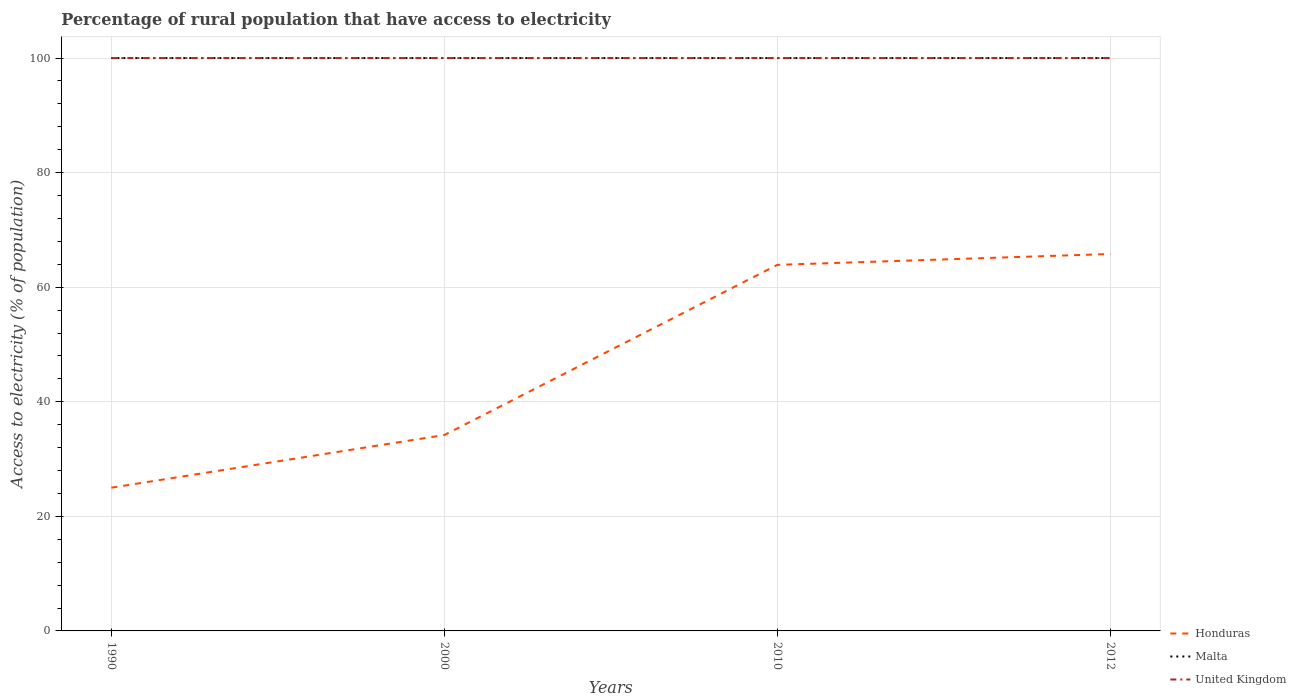How many different coloured lines are there?
Make the answer very short. 3. Does the line corresponding to Honduras intersect with the line corresponding to Malta?
Provide a succinct answer. No. Is the number of lines equal to the number of legend labels?
Provide a succinct answer. Yes. Across all years, what is the maximum percentage of rural population that have access to electricity in Malta?
Keep it short and to the point. 100. What is the difference between the highest and the second highest percentage of rural population that have access to electricity in Honduras?
Provide a short and direct response. 40.8. How many lines are there?
Provide a short and direct response. 3. What is the difference between two consecutive major ticks on the Y-axis?
Provide a short and direct response. 20. Are the values on the major ticks of Y-axis written in scientific E-notation?
Your answer should be compact. No. Does the graph contain grids?
Offer a terse response. Yes. Where does the legend appear in the graph?
Give a very brief answer. Bottom right. How are the legend labels stacked?
Offer a very short reply. Vertical. What is the title of the graph?
Offer a very short reply. Percentage of rural population that have access to electricity. What is the label or title of the X-axis?
Provide a succinct answer. Years. What is the label or title of the Y-axis?
Give a very brief answer. Access to electricity (% of population). What is the Access to electricity (% of population) of United Kingdom in 1990?
Ensure brevity in your answer.  100. What is the Access to electricity (% of population) in Honduras in 2000?
Your answer should be compact. 34.2. What is the Access to electricity (% of population) of Malta in 2000?
Make the answer very short. 100. What is the Access to electricity (% of population) of Honduras in 2010?
Give a very brief answer. 63.9. What is the Access to electricity (% of population) in Honduras in 2012?
Keep it short and to the point. 65.8. What is the Access to electricity (% of population) in Malta in 2012?
Give a very brief answer. 100. What is the Access to electricity (% of population) of United Kingdom in 2012?
Provide a short and direct response. 100. Across all years, what is the maximum Access to electricity (% of population) in Honduras?
Give a very brief answer. 65.8. Across all years, what is the maximum Access to electricity (% of population) in United Kingdom?
Give a very brief answer. 100. Across all years, what is the minimum Access to electricity (% of population) of Honduras?
Your response must be concise. 25. Across all years, what is the minimum Access to electricity (% of population) of Malta?
Provide a succinct answer. 100. Across all years, what is the minimum Access to electricity (% of population) in United Kingdom?
Offer a terse response. 100. What is the total Access to electricity (% of population) of Honduras in the graph?
Your response must be concise. 188.9. What is the total Access to electricity (% of population) in Malta in the graph?
Give a very brief answer. 400. What is the difference between the Access to electricity (% of population) in Malta in 1990 and that in 2000?
Give a very brief answer. 0. What is the difference between the Access to electricity (% of population) of Honduras in 1990 and that in 2010?
Your answer should be compact. -38.9. What is the difference between the Access to electricity (% of population) in Malta in 1990 and that in 2010?
Your answer should be very brief. 0. What is the difference between the Access to electricity (% of population) in United Kingdom in 1990 and that in 2010?
Give a very brief answer. 0. What is the difference between the Access to electricity (% of population) in Honduras in 1990 and that in 2012?
Provide a short and direct response. -40.8. What is the difference between the Access to electricity (% of population) in United Kingdom in 1990 and that in 2012?
Make the answer very short. 0. What is the difference between the Access to electricity (% of population) in Honduras in 2000 and that in 2010?
Offer a terse response. -29.7. What is the difference between the Access to electricity (% of population) in Malta in 2000 and that in 2010?
Provide a succinct answer. 0. What is the difference between the Access to electricity (% of population) in Honduras in 2000 and that in 2012?
Keep it short and to the point. -31.6. What is the difference between the Access to electricity (% of population) of United Kingdom in 2000 and that in 2012?
Your answer should be very brief. 0. What is the difference between the Access to electricity (% of population) in Honduras in 2010 and that in 2012?
Offer a terse response. -1.9. What is the difference between the Access to electricity (% of population) of Malta in 2010 and that in 2012?
Offer a very short reply. 0. What is the difference between the Access to electricity (% of population) in United Kingdom in 2010 and that in 2012?
Provide a succinct answer. 0. What is the difference between the Access to electricity (% of population) in Honduras in 1990 and the Access to electricity (% of population) in Malta in 2000?
Ensure brevity in your answer.  -75. What is the difference between the Access to electricity (% of population) in Honduras in 1990 and the Access to electricity (% of population) in United Kingdom in 2000?
Give a very brief answer. -75. What is the difference between the Access to electricity (% of population) in Malta in 1990 and the Access to electricity (% of population) in United Kingdom in 2000?
Provide a short and direct response. 0. What is the difference between the Access to electricity (% of population) in Honduras in 1990 and the Access to electricity (% of population) in Malta in 2010?
Your answer should be compact. -75. What is the difference between the Access to electricity (% of population) in Honduras in 1990 and the Access to electricity (% of population) in United Kingdom in 2010?
Keep it short and to the point. -75. What is the difference between the Access to electricity (% of population) of Malta in 1990 and the Access to electricity (% of population) of United Kingdom in 2010?
Keep it short and to the point. 0. What is the difference between the Access to electricity (% of population) in Honduras in 1990 and the Access to electricity (% of population) in Malta in 2012?
Your answer should be compact. -75. What is the difference between the Access to electricity (% of population) in Honduras in 1990 and the Access to electricity (% of population) in United Kingdom in 2012?
Offer a terse response. -75. What is the difference between the Access to electricity (% of population) of Malta in 1990 and the Access to electricity (% of population) of United Kingdom in 2012?
Provide a succinct answer. 0. What is the difference between the Access to electricity (% of population) in Honduras in 2000 and the Access to electricity (% of population) in Malta in 2010?
Give a very brief answer. -65.8. What is the difference between the Access to electricity (% of population) of Honduras in 2000 and the Access to electricity (% of population) of United Kingdom in 2010?
Ensure brevity in your answer.  -65.8. What is the difference between the Access to electricity (% of population) in Malta in 2000 and the Access to electricity (% of population) in United Kingdom in 2010?
Your response must be concise. 0. What is the difference between the Access to electricity (% of population) of Honduras in 2000 and the Access to electricity (% of population) of Malta in 2012?
Your answer should be very brief. -65.8. What is the difference between the Access to electricity (% of population) in Honduras in 2000 and the Access to electricity (% of population) in United Kingdom in 2012?
Your answer should be compact. -65.8. What is the difference between the Access to electricity (% of population) of Honduras in 2010 and the Access to electricity (% of population) of Malta in 2012?
Make the answer very short. -36.1. What is the difference between the Access to electricity (% of population) of Honduras in 2010 and the Access to electricity (% of population) of United Kingdom in 2012?
Offer a very short reply. -36.1. What is the average Access to electricity (% of population) in Honduras per year?
Give a very brief answer. 47.23. What is the average Access to electricity (% of population) of United Kingdom per year?
Your response must be concise. 100. In the year 1990, what is the difference between the Access to electricity (% of population) in Honduras and Access to electricity (% of population) in Malta?
Make the answer very short. -75. In the year 1990, what is the difference between the Access to electricity (% of population) of Honduras and Access to electricity (% of population) of United Kingdom?
Your answer should be compact. -75. In the year 1990, what is the difference between the Access to electricity (% of population) in Malta and Access to electricity (% of population) in United Kingdom?
Offer a terse response. 0. In the year 2000, what is the difference between the Access to electricity (% of population) in Honduras and Access to electricity (% of population) in Malta?
Make the answer very short. -65.8. In the year 2000, what is the difference between the Access to electricity (% of population) in Honduras and Access to electricity (% of population) in United Kingdom?
Your response must be concise. -65.8. In the year 2010, what is the difference between the Access to electricity (% of population) in Honduras and Access to electricity (% of population) in Malta?
Offer a very short reply. -36.1. In the year 2010, what is the difference between the Access to electricity (% of population) of Honduras and Access to electricity (% of population) of United Kingdom?
Your response must be concise. -36.1. In the year 2012, what is the difference between the Access to electricity (% of population) of Honduras and Access to electricity (% of population) of Malta?
Give a very brief answer. -34.2. In the year 2012, what is the difference between the Access to electricity (% of population) of Honduras and Access to electricity (% of population) of United Kingdom?
Offer a very short reply. -34.2. In the year 2012, what is the difference between the Access to electricity (% of population) in Malta and Access to electricity (% of population) in United Kingdom?
Offer a very short reply. 0. What is the ratio of the Access to electricity (% of population) of Honduras in 1990 to that in 2000?
Keep it short and to the point. 0.73. What is the ratio of the Access to electricity (% of population) of Malta in 1990 to that in 2000?
Keep it short and to the point. 1. What is the ratio of the Access to electricity (% of population) in Honduras in 1990 to that in 2010?
Offer a terse response. 0.39. What is the ratio of the Access to electricity (% of population) in United Kingdom in 1990 to that in 2010?
Make the answer very short. 1. What is the ratio of the Access to electricity (% of population) of Honduras in 1990 to that in 2012?
Your response must be concise. 0.38. What is the ratio of the Access to electricity (% of population) in Malta in 1990 to that in 2012?
Provide a succinct answer. 1. What is the ratio of the Access to electricity (% of population) of Honduras in 2000 to that in 2010?
Keep it short and to the point. 0.54. What is the ratio of the Access to electricity (% of population) in United Kingdom in 2000 to that in 2010?
Ensure brevity in your answer.  1. What is the ratio of the Access to electricity (% of population) in Honduras in 2000 to that in 2012?
Provide a succinct answer. 0.52. What is the ratio of the Access to electricity (% of population) of United Kingdom in 2000 to that in 2012?
Give a very brief answer. 1. What is the ratio of the Access to electricity (% of population) in Honduras in 2010 to that in 2012?
Ensure brevity in your answer.  0.97. What is the ratio of the Access to electricity (% of population) in Malta in 2010 to that in 2012?
Give a very brief answer. 1. What is the difference between the highest and the second highest Access to electricity (% of population) in Malta?
Ensure brevity in your answer.  0. What is the difference between the highest and the lowest Access to electricity (% of population) in Honduras?
Make the answer very short. 40.8. What is the difference between the highest and the lowest Access to electricity (% of population) in Malta?
Offer a very short reply. 0. What is the difference between the highest and the lowest Access to electricity (% of population) in United Kingdom?
Your response must be concise. 0. 